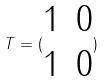Convert formula to latex. <formula><loc_0><loc_0><loc_500><loc_500>T = ( \begin{matrix} 1 & 0 \\ 1 & 0 \end{matrix} )</formula> 